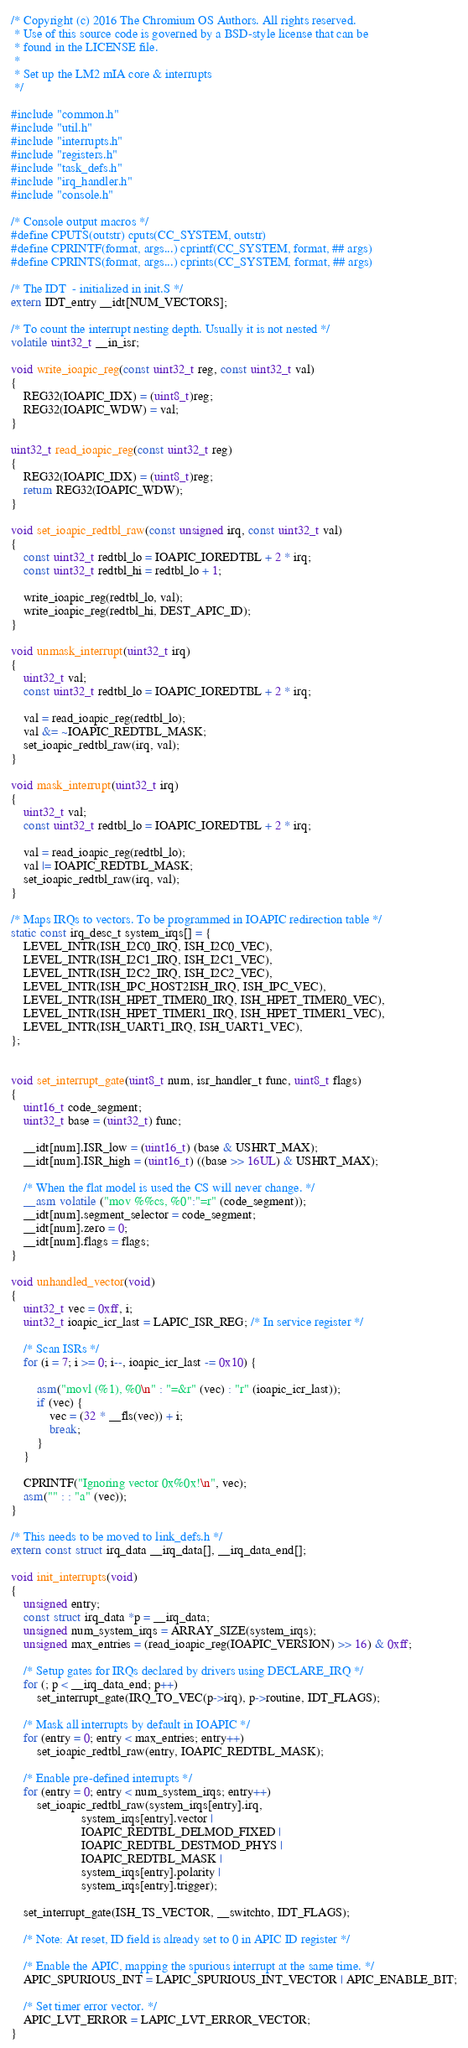<code> <loc_0><loc_0><loc_500><loc_500><_C_>/* Copyright (c) 2016 The Chromium OS Authors. All rights reserved.
 * Use of this source code is governed by a BSD-style license that can be
 * found in the LICENSE file.
 *
 * Set up the LM2 mIA core & interrupts
 */

#include "common.h"
#include "util.h"
#include "interrupts.h"
#include "registers.h"
#include "task_defs.h"
#include "irq_handler.h"
#include "console.h"

/* Console output macros */
#define CPUTS(outstr) cputs(CC_SYSTEM, outstr)
#define CPRINTF(format, args...) cprintf(CC_SYSTEM, format, ## args)
#define CPRINTS(format, args...) cprints(CC_SYSTEM, format, ## args)

/* The IDT  - initialized in init.S */
extern IDT_entry __idt[NUM_VECTORS];

/* To count the interrupt nesting depth. Usually it is not nested */
volatile uint32_t __in_isr;

void write_ioapic_reg(const uint32_t reg, const uint32_t val)
{
	REG32(IOAPIC_IDX) = (uint8_t)reg;
	REG32(IOAPIC_WDW) = val;
}

uint32_t read_ioapic_reg(const uint32_t reg)
{
	REG32(IOAPIC_IDX) = (uint8_t)reg;
	return REG32(IOAPIC_WDW);
}

void set_ioapic_redtbl_raw(const unsigned irq, const uint32_t val)
{
	const uint32_t redtbl_lo = IOAPIC_IOREDTBL + 2 * irq;
	const uint32_t redtbl_hi = redtbl_lo + 1;

	write_ioapic_reg(redtbl_lo, val);
	write_ioapic_reg(redtbl_hi, DEST_APIC_ID);
}

void unmask_interrupt(uint32_t irq)
{
	uint32_t val;
	const uint32_t redtbl_lo = IOAPIC_IOREDTBL + 2 * irq;

	val = read_ioapic_reg(redtbl_lo);
	val &= ~IOAPIC_REDTBL_MASK;
	set_ioapic_redtbl_raw(irq, val);
}

void mask_interrupt(uint32_t irq)
{
	uint32_t val;
	const uint32_t redtbl_lo = IOAPIC_IOREDTBL + 2 * irq;

	val = read_ioapic_reg(redtbl_lo);
	val |= IOAPIC_REDTBL_MASK;
	set_ioapic_redtbl_raw(irq, val);
}

/* Maps IRQs to vectors. To be programmed in IOAPIC redirection table */
static const irq_desc_t system_irqs[] = {
	LEVEL_INTR(ISH_I2C0_IRQ, ISH_I2C0_VEC),
	LEVEL_INTR(ISH_I2C1_IRQ, ISH_I2C1_VEC),
	LEVEL_INTR(ISH_I2C2_IRQ, ISH_I2C2_VEC),
	LEVEL_INTR(ISH_IPC_HOST2ISH_IRQ, ISH_IPC_VEC),
	LEVEL_INTR(ISH_HPET_TIMER0_IRQ, ISH_HPET_TIMER0_VEC),
	LEVEL_INTR(ISH_HPET_TIMER1_IRQ, ISH_HPET_TIMER1_VEC),
	LEVEL_INTR(ISH_UART1_IRQ, ISH_UART1_VEC),
};


void set_interrupt_gate(uint8_t num, isr_handler_t func, uint8_t flags)
{
	uint16_t code_segment;
	uint32_t base = (uint32_t) func;

	__idt[num].ISR_low = (uint16_t) (base & USHRT_MAX);
	__idt[num].ISR_high = (uint16_t) ((base >> 16UL) & USHRT_MAX);

	/* When the flat model is used the CS will never change. */
	__asm volatile ("mov %%cs, %0":"=r" (code_segment));
	__idt[num].segment_selector = code_segment;
	__idt[num].zero = 0;
	__idt[num].flags = flags;
}

void unhandled_vector(void)
{
	uint32_t vec = 0xff, i;
	uint32_t ioapic_icr_last = LAPIC_ISR_REG; /* In service register */

	/* Scan ISRs */
	for (i = 7; i >= 0; i--, ioapic_icr_last -= 0x10) {

		asm("movl (%1), %0\n" : "=&r" (vec) : "r" (ioapic_icr_last));
		if (vec) {
			vec = (32 * __fls(vec)) + i;
			break;
		}
	}

	CPRINTF("Ignoring vector 0x%0x!\n", vec);
	asm("" : : "a" (vec));
}

/* This needs to be moved to link_defs.h */
extern const struct irq_data __irq_data[], __irq_data_end[];

void init_interrupts(void)
{
	unsigned entry;
	const struct irq_data *p = __irq_data;
	unsigned num_system_irqs = ARRAY_SIZE(system_irqs);
	unsigned max_entries = (read_ioapic_reg(IOAPIC_VERSION) >> 16) & 0xff;

	/* Setup gates for IRQs declared by drivers using DECLARE_IRQ */
	for (; p < __irq_data_end; p++)
		set_interrupt_gate(IRQ_TO_VEC(p->irq), p->routine, IDT_FLAGS);

	/* Mask all interrupts by default in IOAPIC */
	for (entry = 0; entry < max_entries; entry++)
		set_ioapic_redtbl_raw(entry, IOAPIC_REDTBL_MASK);

	/* Enable pre-defined interrupts */
	for (entry = 0; entry < num_system_irqs; entry++)
		set_ioapic_redtbl_raw(system_irqs[entry].irq,
				      system_irqs[entry].vector |
				      IOAPIC_REDTBL_DELMOD_FIXED |
				      IOAPIC_REDTBL_DESTMOD_PHYS |
				      IOAPIC_REDTBL_MASK |
				      system_irqs[entry].polarity |
				      system_irqs[entry].trigger);

	set_interrupt_gate(ISH_TS_VECTOR, __switchto, IDT_FLAGS);

	/* Note: At reset, ID field is already set to 0 in APIC ID register */

	/* Enable the APIC, mapping the spurious interrupt at the same time. */
	APIC_SPURIOUS_INT = LAPIC_SPURIOUS_INT_VECTOR | APIC_ENABLE_BIT;

	/* Set timer error vector. */
	APIC_LVT_ERROR = LAPIC_LVT_ERROR_VECTOR;
}
</code> 